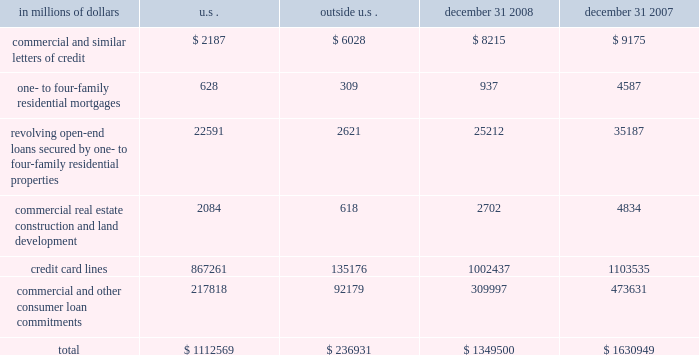Credit commitments the table below summarizes citigroup 2019s other commitments as of december 31 , 2008 and december 31 , 2007 .
In millions of dollars u.s .
Outside december 31 , december 31 .
The majority of unused commitments are contingent upon customers 2019 maintaining specific credit standards .
Commercial commitments generally have floating interest rates and fixed expiration dates and may require payment of fees .
Such fees ( net of certain direct costs ) are deferred and , upon exercise of the commitment , amortized over the life of the loan or , if exercise is deemed remote , amortized over the commitment period .
Commercial and similar letters of credit a commercial letter of credit is an instrument by which citigroup substitutes its credit for that of a customer to enable the customer to finance the purchase of goods or to incur other commitments .
Citigroup issues a letter on behalf of its client to a supplier and agrees to pay the supplier upon presentation of documentary evidence that the supplier has performed in accordance with the terms of the letter of credit .
When drawn , the customer then is required to reimburse citigroup .
One- to four-family residential mortgages a one- to four-family residential mortgage commitment is a written confirmation from citigroup to a seller of a property that the bank will advance the specified sums enabling the buyer to complete the purchase .
Revolving open-end loans secured by one- to four-family residential properties revolving open-end loans secured by one- to four-family residential properties are essentially home equity lines of credit .
A home equity line of credit is a loan secured by a primary residence or second home to the extent of the excess of fair market value over the debt outstanding for the first mortgage .
Commercial real estate , construction and land development commercial real estate , construction and land development include unused portions of commitments to extend credit for the purpose of financing commercial and multifamily residential properties as well as land development projects .
Both secured-by-real-estate and unsecured commitments are included in this line .
In addition , undistributed loan proceeds , where there is an obligation to advance for construction progress , payments are also included in this line .
However , this line only includes those extensions of credit that once funded will be classified as loans on the consolidated balance sheet .
Credit card lines citigroup provides credit to customers by issuing credit cards .
The credit card lines are unconditionally cancellable by the issuer .
Commercial and other consumer loan commitments commercial and other consumer loan commitments include commercial commitments to make or purchase loans , to purchase third-party receivables and to provide note issuance or revolving underwriting facilities .
Amounts include $ 140 billion and $ 259 billion with an original maturity of less than one year at december 31 , 2008 and december 31 , 2007 , respectively .
In addition , included in this line item are highly leveraged financing commitments which are agreements that provide funding to a borrower with higher levels of debt ( measured by the ratio of debt capital to equity capital of the borrower ) than is generally considered normal for other companies .
This type of financing is commonly employed in corporate acquisitions , management buy-outs and similar transactions. .
What percentage of citigroup 2019s total other commitments as of december 31 , 2008 are outside the u.s.? 
Computations: (236931 / 1349500)
Answer: 0.17557. 